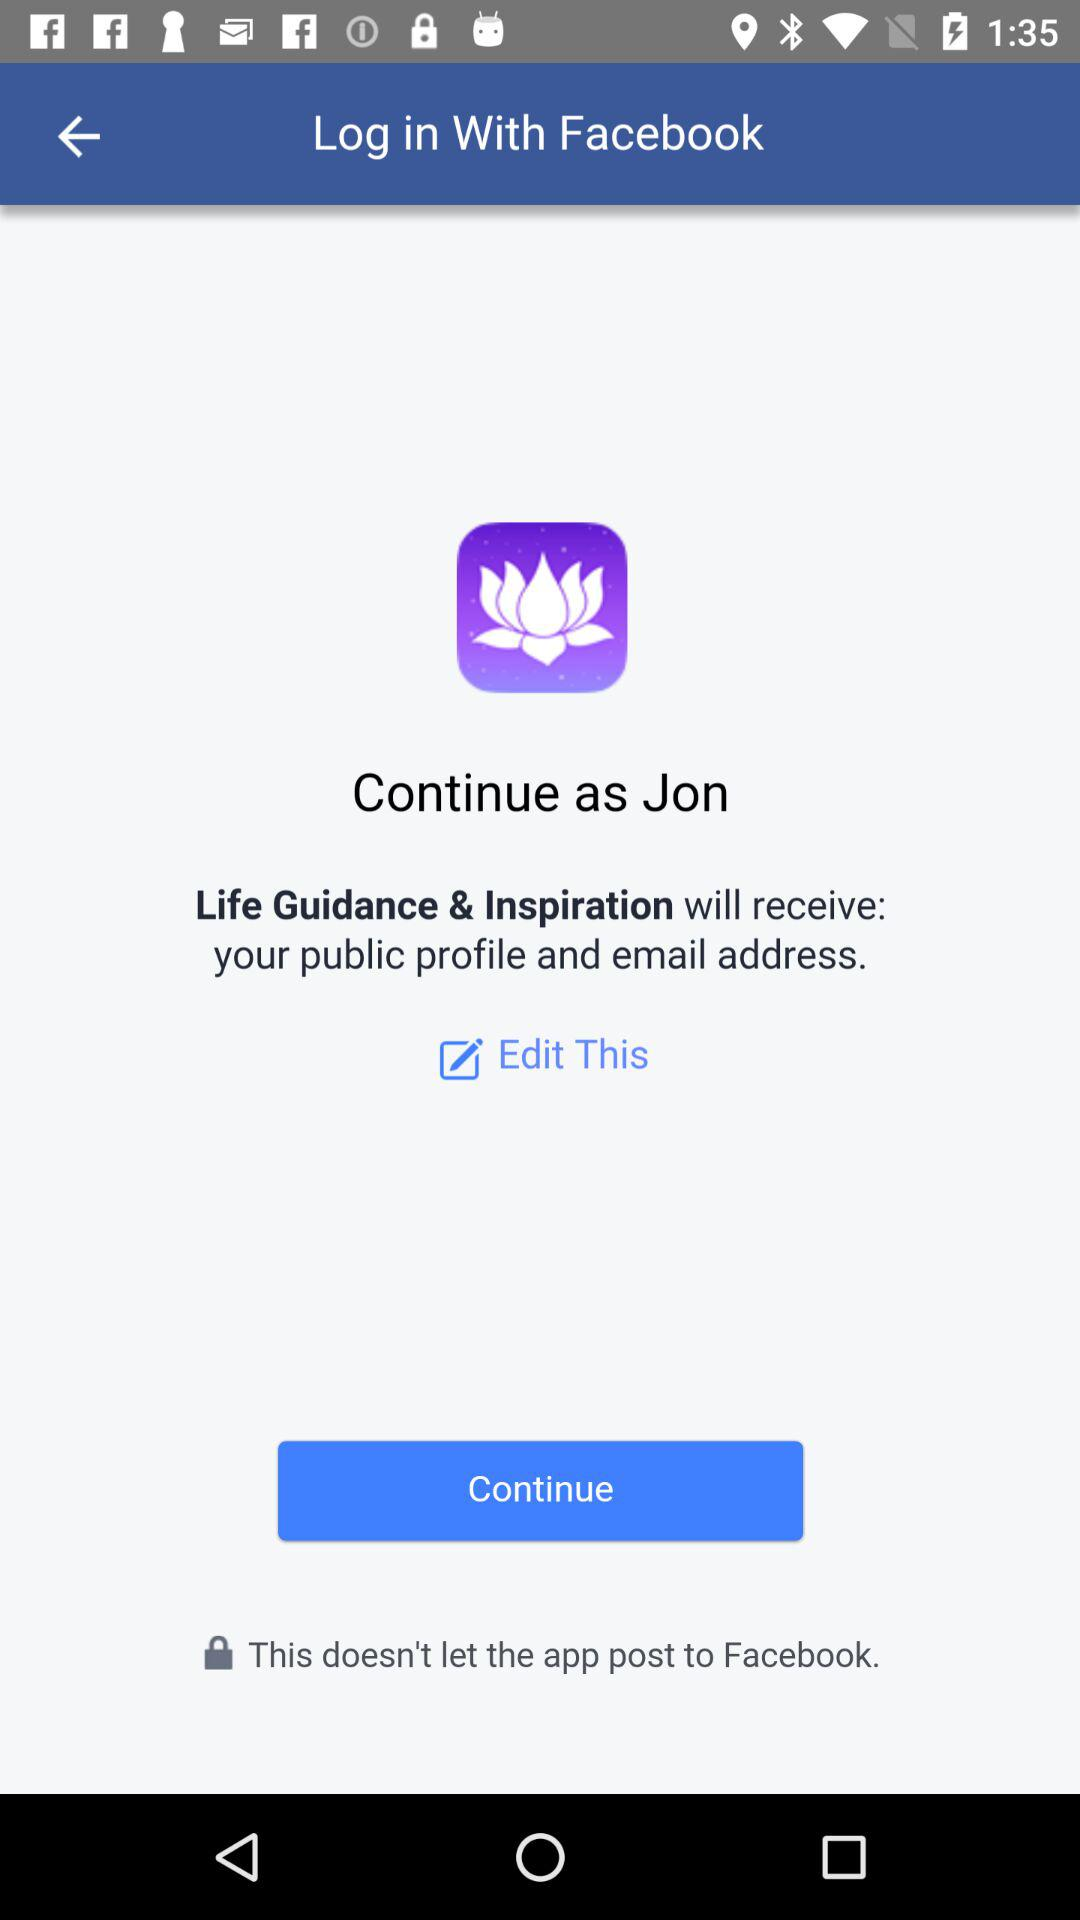What is the application name? The application names are "Facebook" and "Life Guidance & Inspiration". 